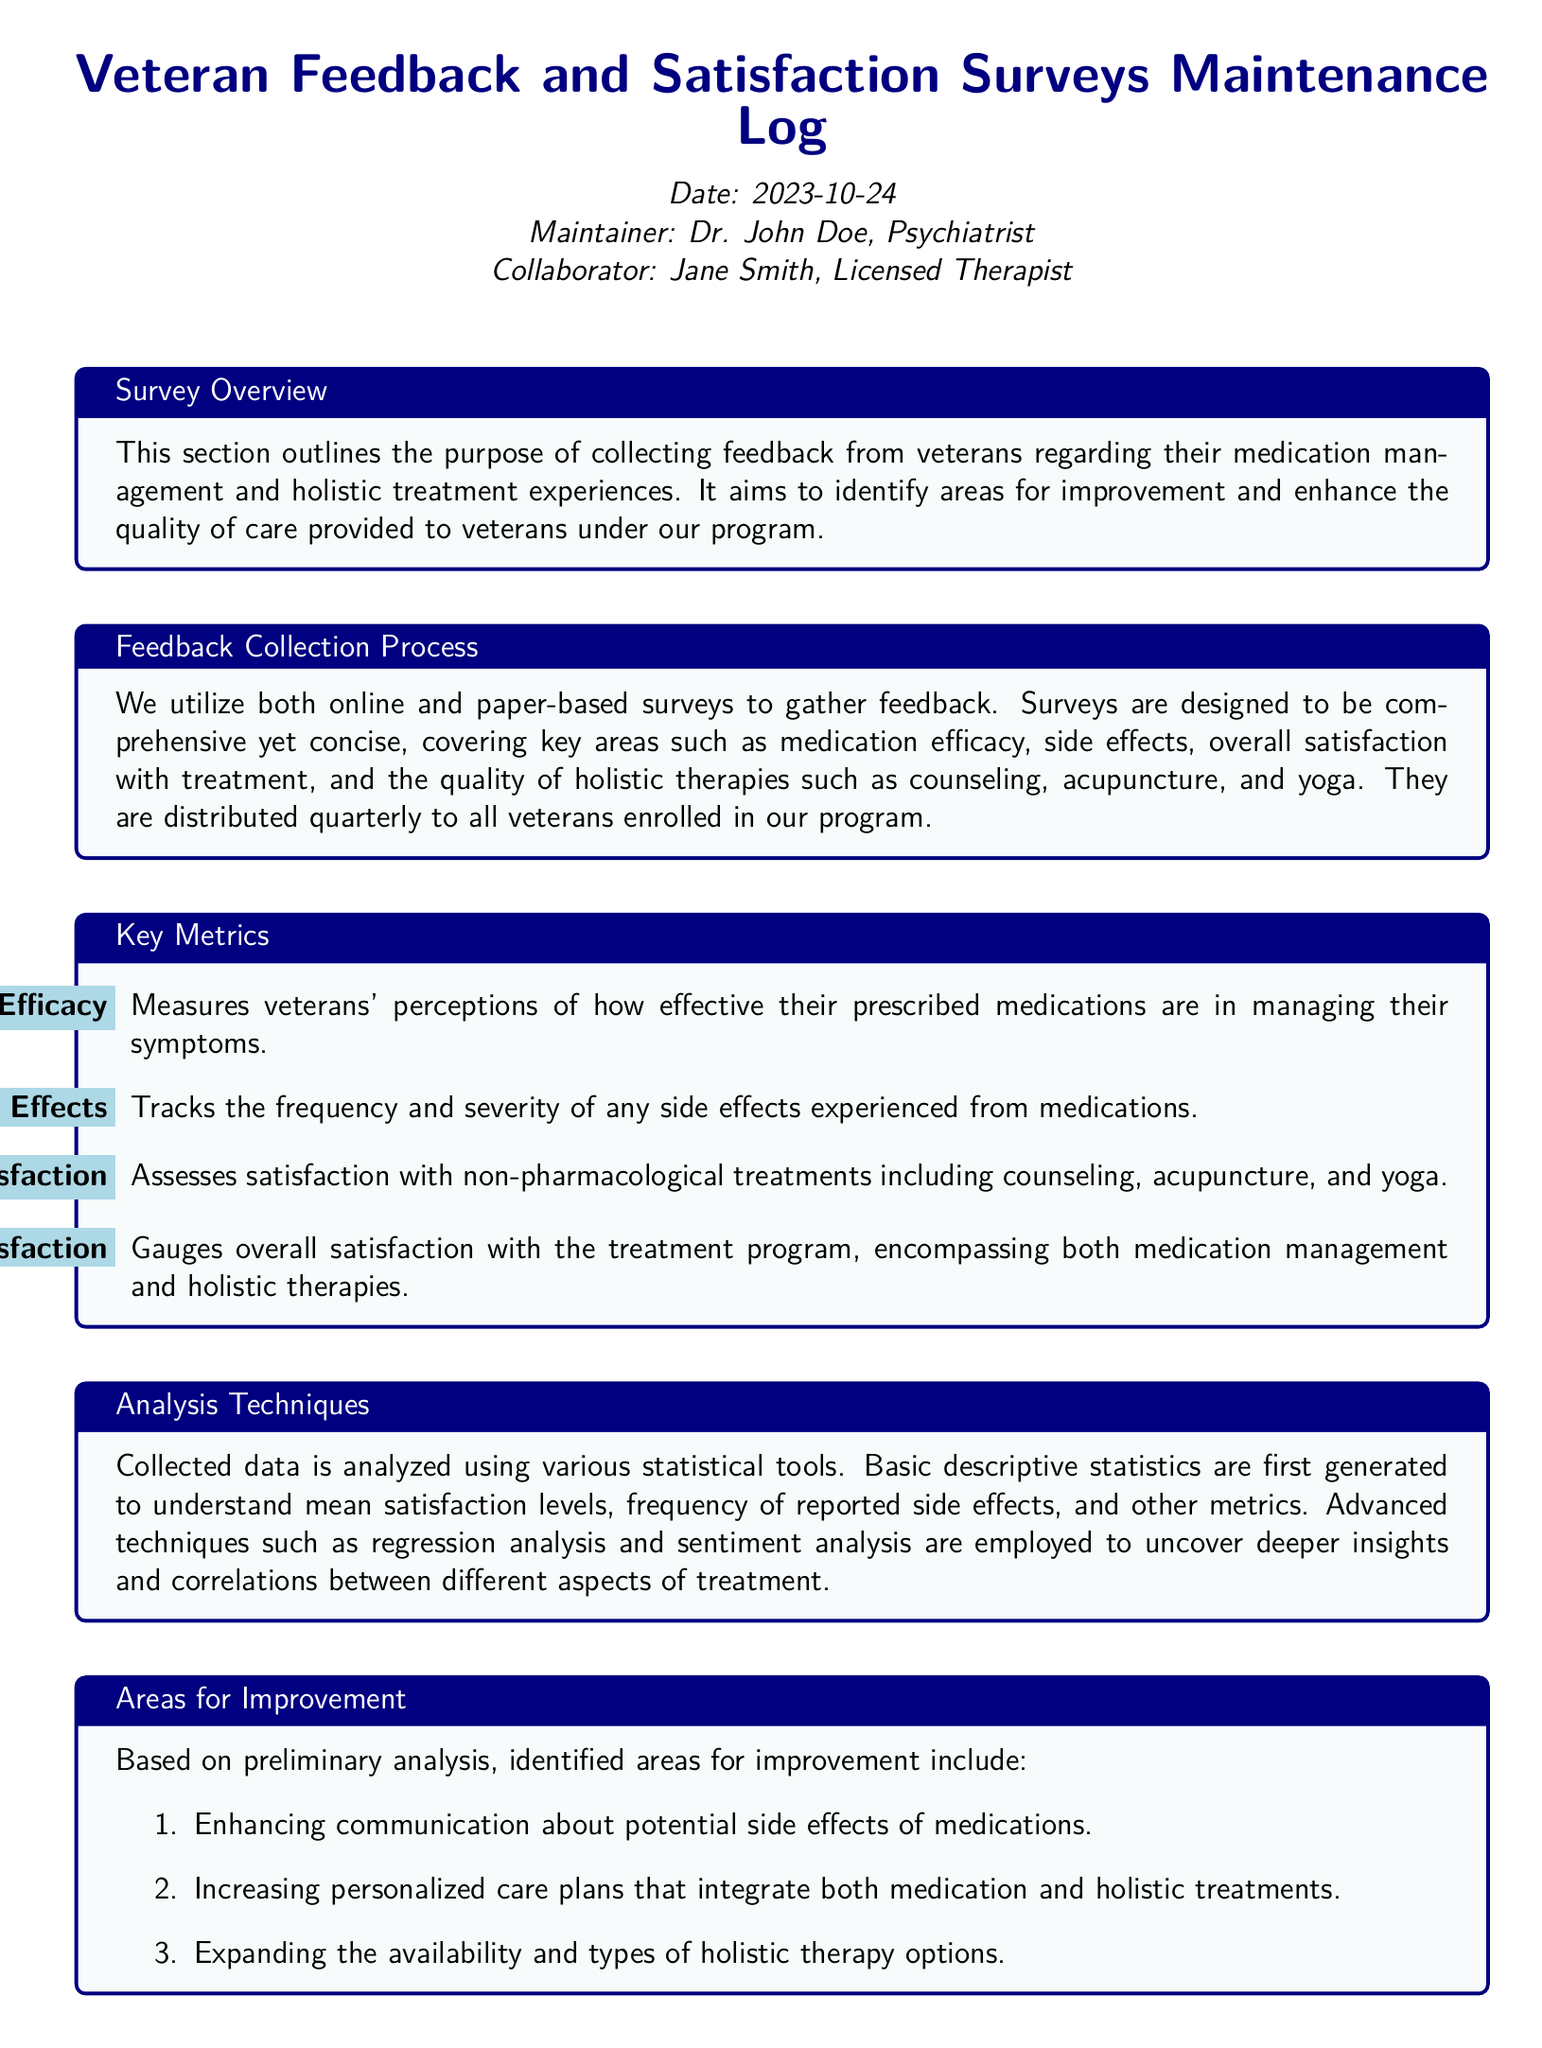what is the date of the maintenance log? The date is mentioned at the beginning of the document under the 'Date' section.
Answer: 2023-10-24 who is the maintainer of the log? The maintainer's name is listed under the 'Maintainer' section.
Answer: Dr. John Doe what is one of the key metrics for assessing holistic therapies? The metrics are listed in the 'Key Metrics' section, focusing on various aspects of treatment.
Answer: Holistic Therapies Satisfaction how often are surveys distributed to veterans? The frequency of survey distribution is indicated in the 'Feedback Collection Process' section.
Answer: Quarterly what is one area for improvement identified from the survey analysis? Areas for improvement are outlined in the 'Areas for Improvement' section.
Answer: Enhancing communication about potential side effects what statistical methods are used for data analysis? The analysis techniques are provided in the 'Analysis Techniques' section.
Answer: Regression analysis how many actionable steps are mentioned in the action plan? The 'Action Plan' section includes a reference to actionable steps.
Answer: Three who collaborates with the maintainer in this log? The collaborator's information is provided at the beginning of the document.
Answer: Jane Smith 